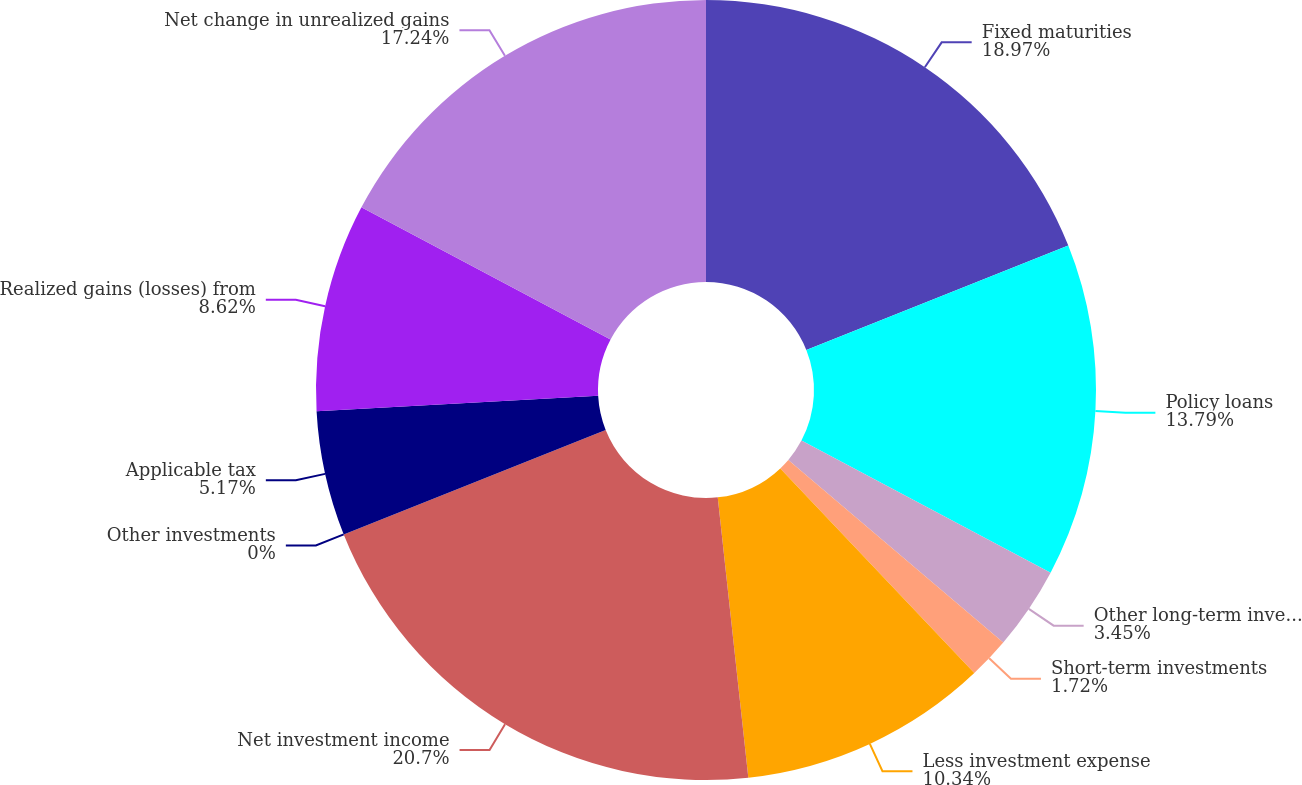<chart> <loc_0><loc_0><loc_500><loc_500><pie_chart><fcel>Fixed maturities<fcel>Policy loans<fcel>Other long-term investments<fcel>Short-term investments<fcel>Less investment expense<fcel>Net investment income<fcel>Other investments<fcel>Applicable tax<fcel>Realized gains (losses) from<fcel>Net change in unrealized gains<nl><fcel>18.96%<fcel>13.79%<fcel>3.45%<fcel>1.72%<fcel>10.34%<fcel>20.69%<fcel>0.0%<fcel>5.17%<fcel>8.62%<fcel>17.24%<nl></chart> 